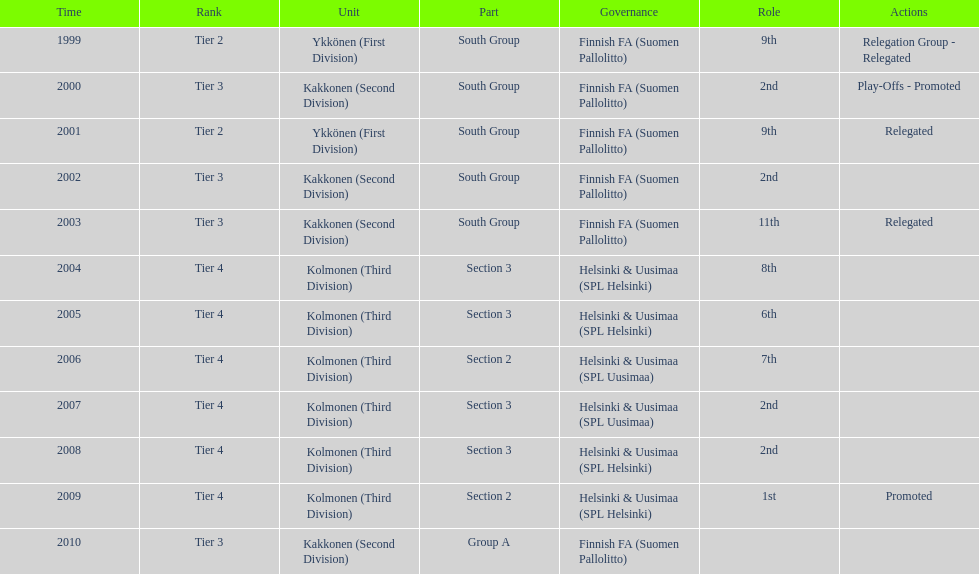How many tiers had more than one relegated movement? 1. 